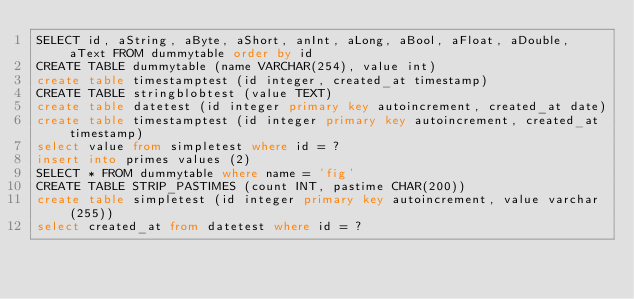Convert code to text. <code><loc_0><loc_0><loc_500><loc_500><_SQL_>SELECT id, aString, aByte, aShort, anInt, aLong, aBool, aFloat, aDouble, aText FROM dummytable order by id
CREATE TABLE dummytable (name VARCHAR(254), value int)
create table timestamptest (id integer, created_at timestamp)
CREATE TABLE stringblobtest (value TEXT)
create table datetest (id integer primary key autoincrement, created_at date)
create table timestamptest (id integer primary key autoincrement, created_at timestamp)
select value from simpletest where id = ?
insert into primes values (2)
SELECT * FROM dummytable where name = 'fig'
CREATE TABLE STRIP_PASTIMES (count INT, pastime CHAR(200))
create table simpletest (id integer primary key autoincrement, value varchar(255))
select created_at from datetest where id = ?
</code> 